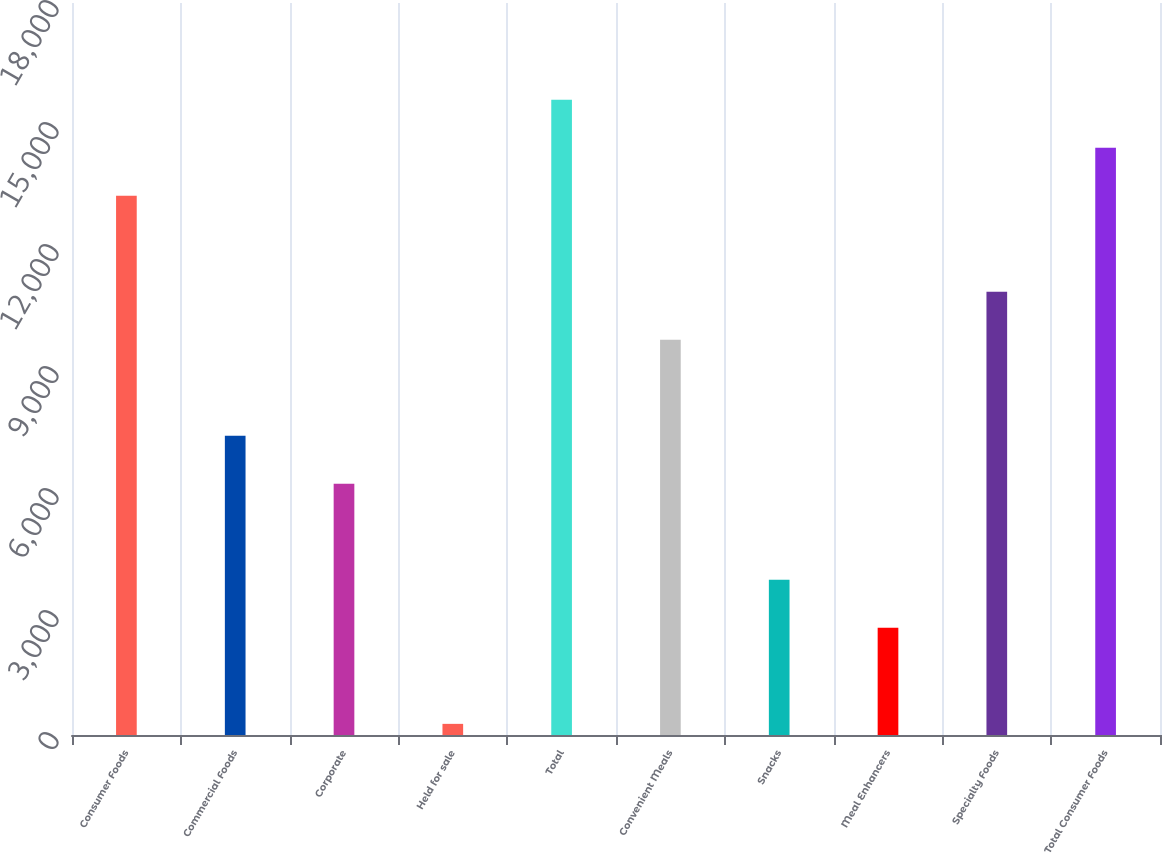<chart> <loc_0><loc_0><loc_500><loc_500><bar_chart><fcel>Consumer Foods<fcel>Commercial Foods<fcel>Corporate<fcel>Held for sale<fcel>Total<fcel>Convenient Meals<fcel>Snacks<fcel>Meal Enhancers<fcel>Specialty Foods<fcel>Total Consumer Foods<nl><fcel>13260<fcel>7357.2<fcel>6176.65<fcel>273.9<fcel>15621<fcel>9718.3<fcel>3815.55<fcel>2635<fcel>10898.9<fcel>14440.5<nl></chart> 